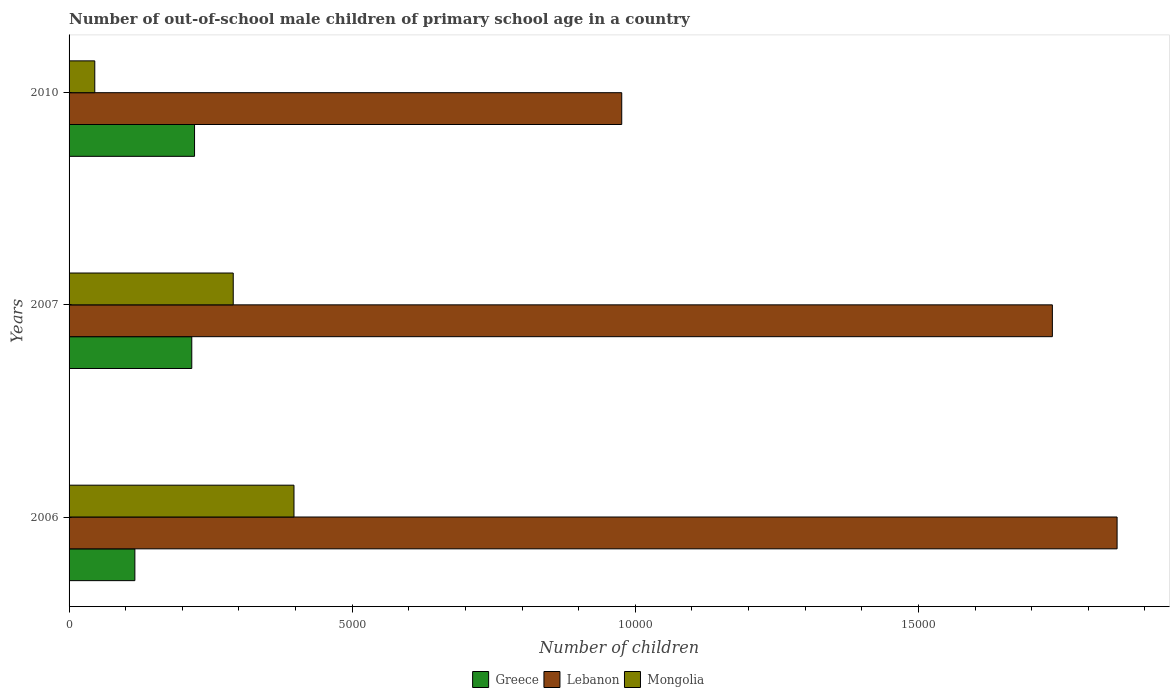How many groups of bars are there?
Provide a succinct answer. 3. Are the number of bars per tick equal to the number of legend labels?
Ensure brevity in your answer.  Yes. How many bars are there on the 3rd tick from the top?
Offer a terse response. 3. How many bars are there on the 3rd tick from the bottom?
Provide a short and direct response. 3. In how many cases, is the number of bars for a given year not equal to the number of legend labels?
Keep it short and to the point. 0. What is the number of out-of-school male children in Lebanon in 2007?
Offer a very short reply. 1.74e+04. Across all years, what is the maximum number of out-of-school male children in Greece?
Keep it short and to the point. 2216. Across all years, what is the minimum number of out-of-school male children in Mongolia?
Your response must be concise. 454. In which year was the number of out-of-school male children in Lebanon maximum?
Ensure brevity in your answer.  2006. In which year was the number of out-of-school male children in Mongolia minimum?
Offer a terse response. 2010. What is the total number of out-of-school male children in Mongolia in the graph?
Offer a terse response. 7325. What is the difference between the number of out-of-school male children in Lebanon in 2006 and that in 2010?
Offer a terse response. 8748. What is the difference between the number of out-of-school male children in Greece in 2006 and the number of out-of-school male children in Mongolia in 2007?
Offer a terse response. -1737. What is the average number of out-of-school male children in Greece per year?
Provide a succinct answer. 1848.33. In the year 2010, what is the difference between the number of out-of-school male children in Lebanon and number of out-of-school male children in Mongolia?
Offer a very short reply. 9306. What is the ratio of the number of out-of-school male children in Greece in 2006 to that in 2010?
Offer a terse response. 0.52. What is the difference between the highest and the second highest number of out-of-school male children in Mongolia?
Ensure brevity in your answer.  1073. What is the difference between the highest and the lowest number of out-of-school male children in Greece?
Offer a terse response. 1054. Is the sum of the number of out-of-school male children in Greece in 2006 and 2007 greater than the maximum number of out-of-school male children in Mongolia across all years?
Provide a short and direct response. No. What does the 1st bar from the top in 2006 represents?
Keep it short and to the point. Mongolia. What does the 3rd bar from the bottom in 2010 represents?
Your answer should be compact. Mongolia. How many bars are there?
Your answer should be very brief. 9. What is the difference between two consecutive major ticks on the X-axis?
Make the answer very short. 5000. Does the graph contain any zero values?
Give a very brief answer. No. Does the graph contain grids?
Your answer should be compact. No. How are the legend labels stacked?
Make the answer very short. Horizontal. What is the title of the graph?
Provide a succinct answer. Number of out-of-school male children of primary school age in a country. What is the label or title of the X-axis?
Your answer should be compact. Number of children. What is the label or title of the Y-axis?
Offer a terse response. Years. What is the Number of children of Greece in 2006?
Make the answer very short. 1162. What is the Number of children of Lebanon in 2006?
Your answer should be very brief. 1.85e+04. What is the Number of children of Mongolia in 2006?
Your answer should be very brief. 3972. What is the Number of children of Greece in 2007?
Keep it short and to the point. 2167. What is the Number of children of Lebanon in 2007?
Your answer should be compact. 1.74e+04. What is the Number of children in Mongolia in 2007?
Offer a very short reply. 2899. What is the Number of children of Greece in 2010?
Offer a terse response. 2216. What is the Number of children of Lebanon in 2010?
Provide a succinct answer. 9760. What is the Number of children of Mongolia in 2010?
Keep it short and to the point. 454. Across all years, what is the maximum Number of children in Greece?
Your response must be concise. 2216. Across all years, what is the maximum Number of children of Lebanon?
Provide a short and direct response. 1.85e+04. Across all years, what is the maximum Number of children of Mongolia?
Your answer should be very brief. 3972. Across all years, what is the minimum Number of children of Greece?
Your response must be concise. 1162. Across all years, what is the minimum Number of children of Lebanon?
Ensure brevity in your answer.  9760. Across all years, what is the minimum Number of children in Mongolia?
Make the answer very short. 454. What is the total Number of children of Greece in the graph?
Make the answer very short. 5545. What is the total Number of children in Lebanon in the graph?
Keep it short and to the point. 4.56e+04. What is the total Number of children in Mongolia in the graph?
Provide a short and direct response. 7325. What is the difference between the Number of children in Greece in 2006 and that in 2007?
Your answer should be very brief. -1005. What is the difference between the Number of children of Lebanon in 2006 and that in 2007?
Provide a succinct answer. 1143. What is the difference between the Number of children of Mongolia in 2006 and that in 2007?
Provide a short and direct response. 1073. What is the difference between the Number of children of Greece in 2006 and that in 2010?
Ensure brevity in your answer.  -1054. What is the difference between the Number of children of Lebanon in 2006 and that in 2010?
Ensure brevity in your answer.  8748. What is the difference between the Number of children in Mongolia in 2006 and that in 2010?
Your response must be concise. 3518. What is the difference between the Number of children of Greece in 2007 and that in 2010?
Provide a succinct answer. -49. What is the difference between the Number of children in Lebanon in 2007 and that in 2010?
Your answer should be compact. 7605. What is the difference between the Number of children in Mongolia in 2007 and that in 2010?
Offer a terse response. 2445. What is the difference between the Number of children of Greece in 2006 and the Number of children of Lebanon in 2007?
Your answer should be very brief. -1.62e+04. What is the difference between the Number of children of Greece in 2006 and the Number of children of Mongolia in 2007?
Offer a very short reply. -1737. What is the difference between the Number of children of Lebanon in 2006 and the Number of children of Mongolia in 2007?
Your answer should be compact. 1.56e+04. What is the difference between the Number of children in Greece in 2006 and the Number of children in Lebanon in 2010?
Ensure brevity in your answer.  -8598. What is the difference between the Number of children of Greece in 2006 and the Number of children of Mongolia in 2010?
Make the answer very short. 708. What is the difference between the Number of children of Lebanon in 2006 and the Number of children of Mongolia in 2010?
Offer a terse response. 1.81e+04. What is the difference between the Number of children of Greece in 2007 and the Number of children of Lebanon in 2010?
Your answer should be very brief. -7593. What is the difference between the Number of children in Greece in 2007 and the Number of children in Mongolia in 2010?
Keep it short and to the point. 1713. What is the difference between the Number of children in Lebanon in 2007 and the Number of children in Mongolia in 2010?
Your response must be concise. 1.69e+04. What is the average Number of children in Greece per year?
Give a very brief answer. 1848.33. What is the average Number of children in Lebanon per year?
Your answer should be very brief. 1.52e+04. What is the average Number of children in Mongolia per year?
Provide a succinct answer. 2441.67. In the year 2006, what is the difference between the Number of children of Greece and Number of children of Lebanon?
Offer a terse response. -1.73e+04. In the year 2006, what is the difference between the Number of children of Greece and Number of children of Mongolia?
Give a very brief answer. -2810. In the year 2006, what is the difference between the Number of children in Lebanon and Number of children in Mongolia?
Your answer should be compact. 1.45e+04. In the year 2007, what is the difference between the Number of children of Greece and Number of children of Lebanon?
Provide a succinct answer. -1.52e+04. In the year 2007, what is the difference between the Number of children of Greece and Number of children of Mongolia?
Ensure brevity in your answer.  -732. In the year 2007, what is the difference between the Number of children in Lebanon and Number of children in Mongolia?
Offer a terse response. 1.45e+04. In the year 2010, what is the difference between the Number of children of Greece and Number of children of Lebanon?
Your answer should be compact. -7544. In the year 2010, what is the difference between the Number of children in Greece and Number of children in Mongolia?
Your response must be concise. 1762. In the year 2010, what is the difference between the Number of children in Lebanon and Number of children in Mongolia?
Keep it short and to the point. 9306. What is the ratio of the Number of children in Greece in 2006 to that in 2007?
Your answer should be very brief. 0.54. What is the ratio of the Number of children in Lebanon in 2006 to that in 2007?
Your answer should be very brief. 1.07. What is the ratio of the Number of children of Mongolia in 2006 to that in 2007?
Provide a short and direct response. 1.37. What is the ratio of the Number of children of Greece in 2006 to that in 2010?
Give a very brief answer. 0.52. What is the ratio of the Number of children of Lebanon in 2006 to that in 2010?
Ensure brevity in your answer.  1.9. What is the ratio of the Number of children of Mongolia in 2006 to that in 2010?
Offer a very short reply. 8.75. What is the ratio of the Number of children in Greece in 2007 to that in 2010?
Your answer should be very brief. 0.98. What is the ratio of the Number of children of Lebanon in 2007 to that in 2010?
Your answer should be compact. 1.78. What is the ratio of the Number of children in Mongolia in 2007 to that in 2010?
Make the answer very short. 6.39. What is the difference between the highest and the second highest Number of children in Lebanon?
Ensure brevity in your answer.  1143. What is the difference between the highest and the second highest Number of children of Mongolia?
Give a very brief answer. 1073. What is the difference between the highest and the lowest Number of children in Greece?
Your answer should be very brief. 1054. What is the difference between the highest and the lowest Number of children of Lebanon?
Give a very brief answer. 8748. What is the difference between the highest and the lowest Number of children in Mongolia?
Your response must be concise. 3518. 